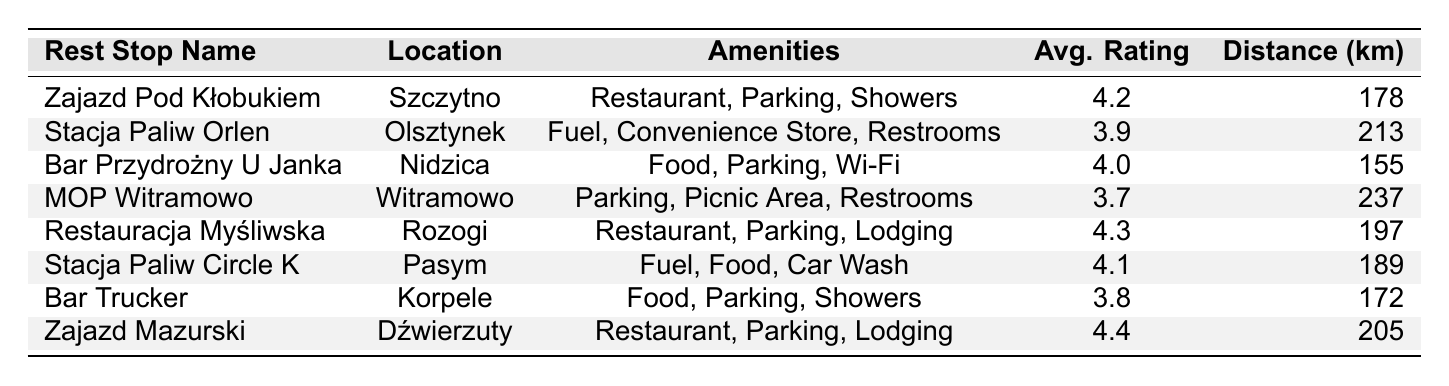What is the name of the rest stop with the highest average rating? The table shows the average ratings of different rest stops. Scanning through the averages, Zajazd Mazurski has the highest average rating of 4.4.
Answer: Zajazd Mazurski How far is Zajazd Pod Kłobukiem from Warsaw? The table lists Zajazd Pod Kłobukiem with a distance of 178 km from Warsaw.
Answer: 178 km Which rest stop is located in Nidzica? Referring to the location column, Bar Przydrożny U Janka is listed as being in Nidzica.
Answer: Bar Przydrożny U Janka How many rest stops have a rating of 4.0 or above? By reviewing the average ratings in the table, there are four rest stops with ratings of 4.0 or above: Zajazd Mazurski (4.4), Restauracja Myśliwska (4.3), Zajazd Pod Kłobukiem (4.2), and Stacja Paliw Circle K (4.1).
Answer: 4 What amenities are available at MOP Witramowo? The table indicates that MOP Witramowo has the following amenities: Parking, Picnic Area, and Restrooms.
Answer: Parking, Picnic Area, Restrooms Which rest stop is the furthest from Warsaw? Looking at the distances, MOP Witramowo is the furthest at 237 km from Warsaw, compared to the others.
Answer: MOP Witramowo Is there a rest stop named Stacja Paliw Circle K? The table confirms the existence of a rest stop named Stacja Paliw Circle K, located in Pasym.
Answer: Yes What is the average distance of all the rest stops from Warsaw? To find the average distance, sum the distances (178 + 213 + 155 + 237 + 197 + 189 + 172 + 205 = 1341) and divide by the number of stops (8). 1341/8 = 167.625 km.
Answer: 167.625 km Which rest stop(s) offer showers? Referring to the amenities section, Zajazd Pod Kłobukiem and Bar Trucker both mention showers.
Answer: Zajazd Pod Kłobukiem, Bar Trucker What is the total number of rest stops that have food as an amenity? Scanning through the amenities, food is offered at Bar Przydrożny U Janka, Stacja Paliw Circle K, Bar Trucker, Restaruacja Myśliwska, and Zajazd Mazurski. This gives us a total of five rest stops.
Answer: 5 